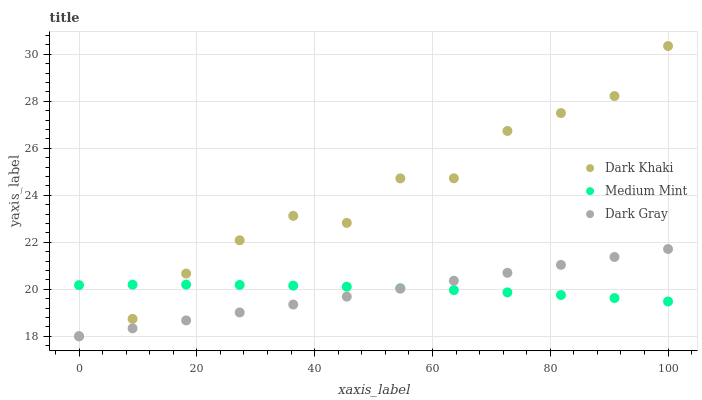Does Dark Gray have the minimum area under the curve?
Answer yes or no. Yes. Does Dark Khaki have the maximum area under the curve?
Answer yes or no. Yes. Does Medium Mint have the minimum area under the curve?
Answer yes or no. No. Does Medium Mint have the maximum area under the curve?
Answer yes or no. No. Is Dark Gray the smoothest?
Answer yes or no. Yes. Is Dark Khaki the roughest?
Answer yes or no. Yes. Is Medium Mint the smoothest?
Answer yes or no. No. Is Medium Mint the roughest?
Answer yes or no. No. Does Dark Khaki have the lowest value?
Answer yes or no. Yes. Does Medium Mint have the lowest value?
Answer yes or no. No. Does Dark Khaki have the highest value?
Answer yes or no. Yes. Does Dark Gray have the highest value?
Answer yes or no. No. Does Dark Gray intersect Dark Khaki?
Answer yes or no. Yes. Is Dark Gray less than Dark Khaki?
Answer yes or no. No. Is Dark Gray greater than Dark Khaki?
Answer yes or no. No. 